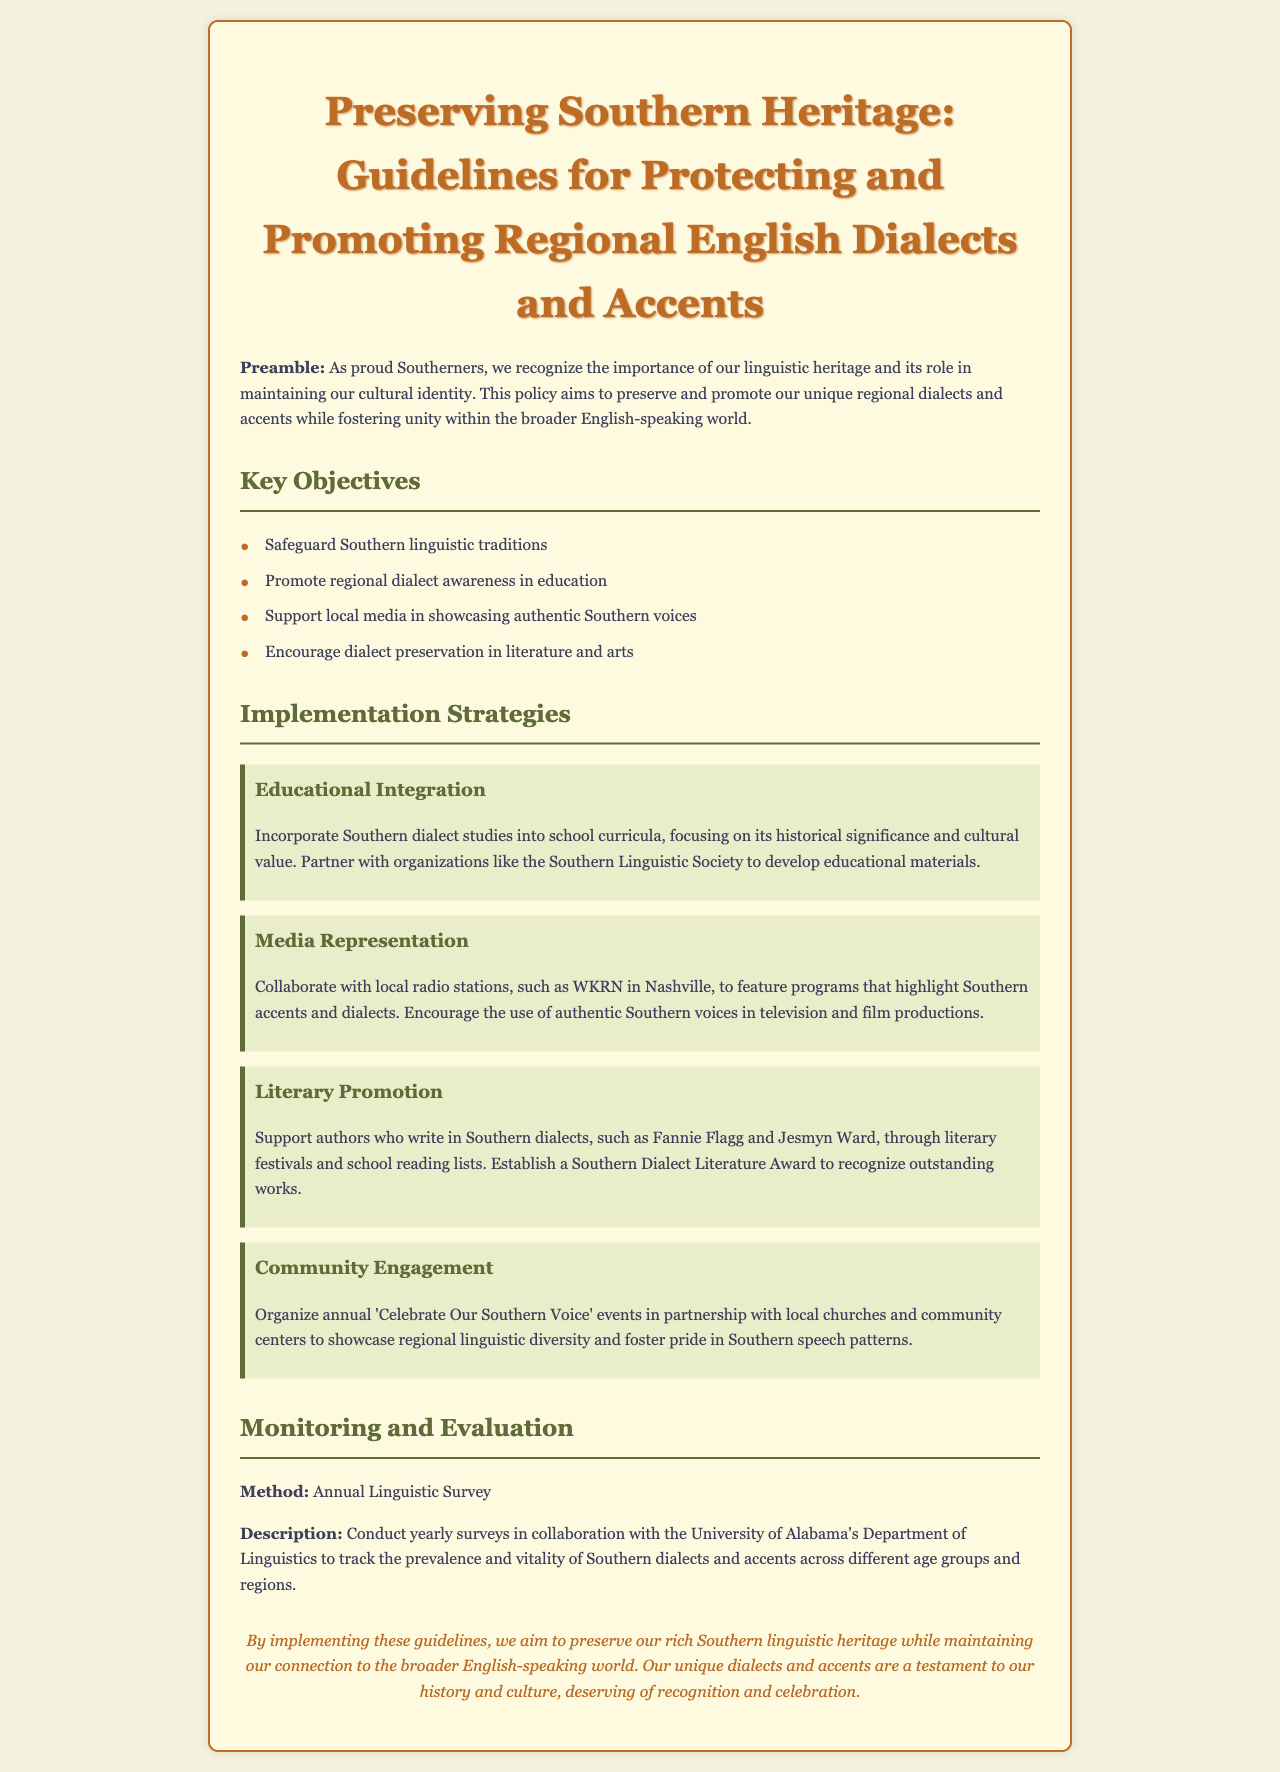What are the key objectives of the policy? The key objectives are listed in the document, which include safeguarding Southern linguistic traditions, promoting regional dialect awareness in education, supporting local media in showcasing authentic Southern voices, and encouraging dialect preservation in literature and arts.
Answer: Safeguard Southern linguistic traditions, Promote regional dialect awareness in education, Support local media in showcasing authentic Southern voices, Encourage dialect preservation in literature and arts Which organization is mentioned for educational partnerships? The document mentions partnering with organizations for educational materials, specifically the Southern Linguistic Society.
Answer: Southern Linguistic Society What events are organized for community engagement? The document describes events aimed at showcasing regional linguistic diversity, specifically the 'Celebrate Our Southern Voice' events.
Answer: Celebrate Our Southern Voice How often is the linguistic survey conducted? The document states that the linguistic survey is conducted yearly.
Answer: Yearly Who is one author mentioned that writes in Southern dialects? The document mentions Fannie Flagg as an author who writes in Southern dialects.
Answer: Fannie Flagg What is the method for monitoring and evaluation? The document states the method for monitoring and evaluation is an Annual Linguistic Survey.
Answer: Annual Linguistic Survey What is the aim of the policy document? The document outlines that the aim is to preserve and promote regional English dialects and accents while fostering unity within the broader English-speaking world.
Answer: Preserve and promote regional English dialects and accents What color scheme is used for the headers? The document uses a color scheme with shades of brown and green for the headers.
Answer: Brown and green 